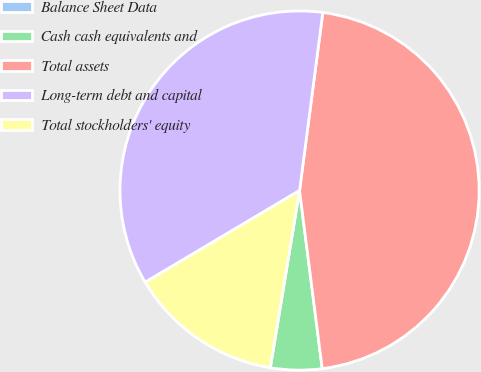Convert chart to OTSL. <chart><loc_0><loc_0><loc_500><loc_500><pie_chart><fcel>Balance Sheet Data<fcel>Cash cash equivalents and<fcel>Total assets<fcel>Long-term debt and capital<fcel>Total stockholders' equity<nl><fcel>0.01%<fcel>4.61%<fcel>45.92%<fcel>35.6%<fcel>13.86%<nl></chart> 